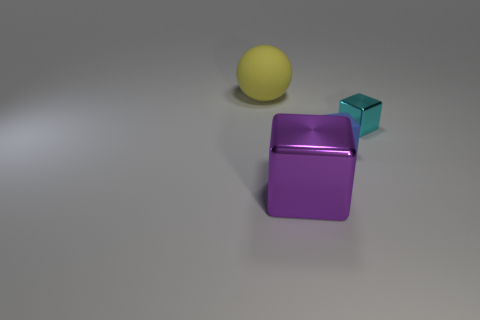Add 4 big yellow matte spheres. How many objects exist? 8 Subtract all blocks. How many objects are left? 1 Subtract all big shiny blocks. Subtract all large purple objects. How many objects are left? 2 Add 2 large purple metallic cubes. How many large purple metallic cubes are left? 3 Add 4 small cyan metal things. How many small cyan metal things exist? 5 Subtract 0 gray balls. How many objects are left? 4 